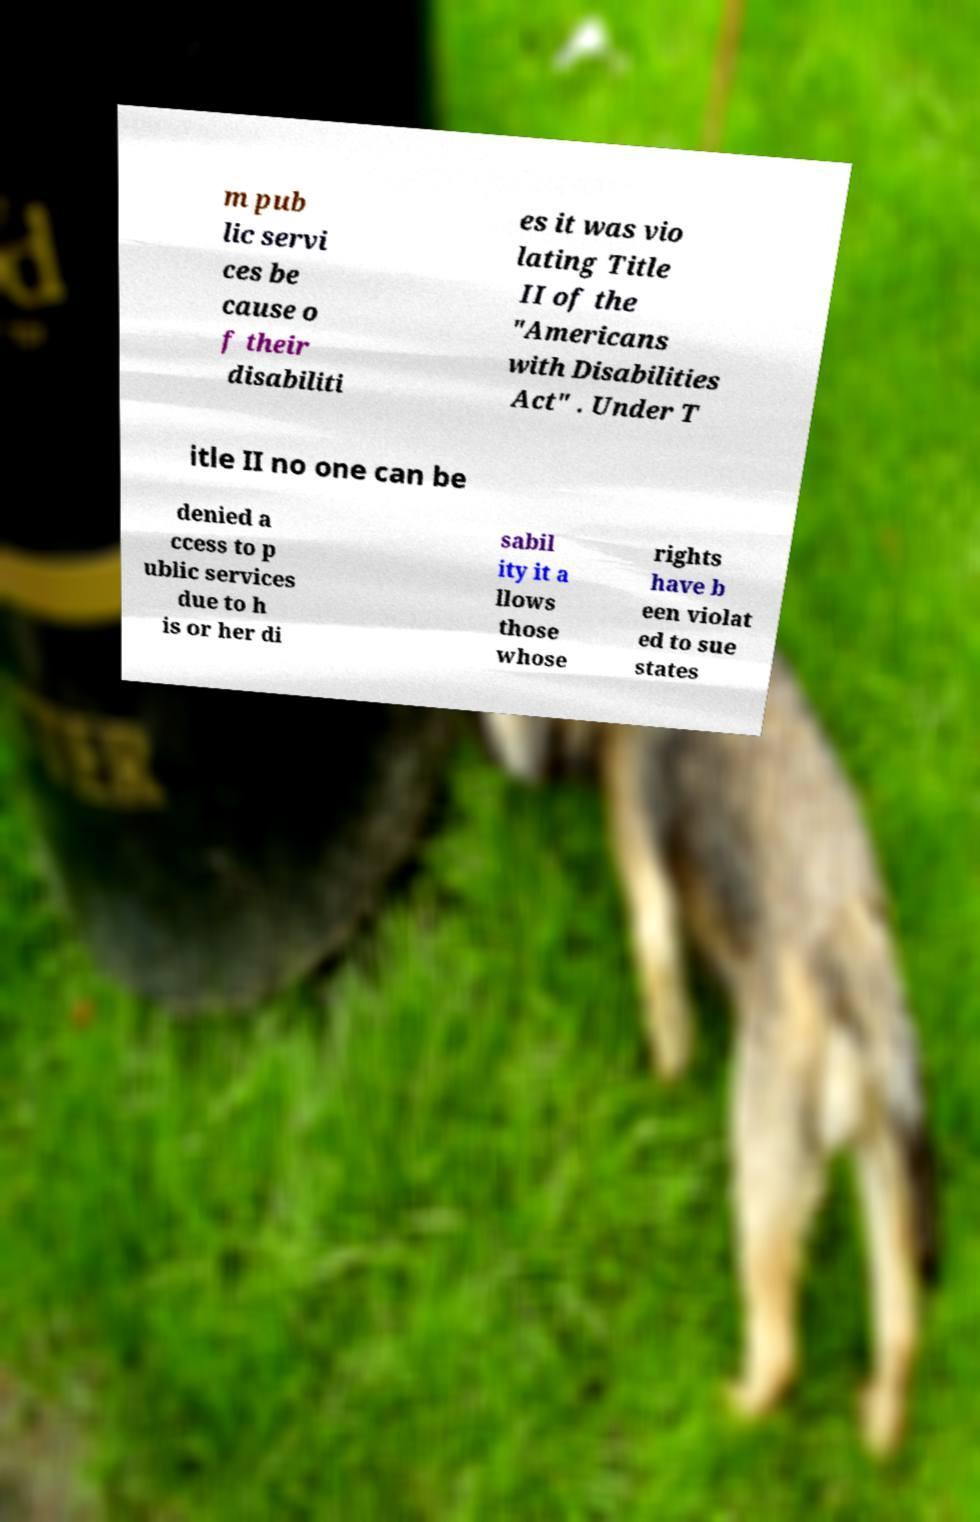Please read and relay the text visible in this image. What does it say? m pub lic servi ces be cause o f their disabiliti es it was vio lating Title II of the "Americans with Disabilities Act" . Under T itle II no one can be denied a ccess to p ublic services due to h is or her di sabil ity it a llows those whose rights have b een violat ed to sue states 